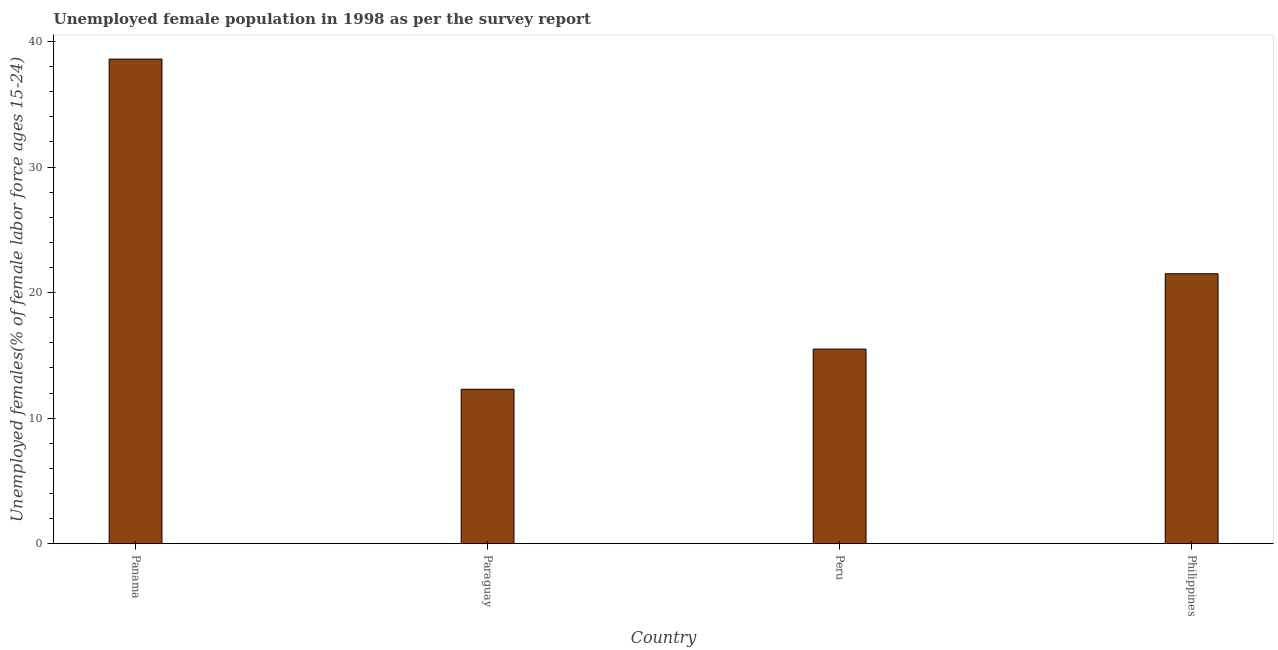What is the title of the graph?
Keep it short and to the point. Unemployed female population in 1998 as per the survey report. What is the label or title of the X-axis?
Provide a short and direct response. Country. What is the label or title of the Y-axis?
Offer a very short reply. Unemployed females(% of female labor force ages 15-24). What is the unemployed female youth in Philippines?
Keep it short and to the point. 21.5. Across all countries, what is the maximum unemployed female youth?
Provide a succinct answer. 38.6. Across all countries, what is the minimum unemployed female youth?
Give a very brief answer. 12.3. In which country was the unemployed female youth maximum?
Provide a short and direct response. Panama. In which country was the unemployed female youth minimum?
Offer a very short reply. Paraguay. What is the sum of the unemployed female youth?
Provide a succinct answer. 87.9. What is the difference between the unemployed female youth in Panama and Paraguay?
Ensure brevity in your answer.  26.3. What is the average unemployed female youth per country?
Provide a short and direct response. 21.98. What is the median unemployed female youth?
Ensure brevity in your answer.  18.5. In how many countries, is the unemployed female youth greater than 24 %?
Ensure brevity in your answer.  1. What is the ratio of the unemployed female youth in Paraguay to that in Peru?
Ensure brevity in your answer.  0.79. Is the difference between the unemployed female youth in Panama and Paraguay greater than the difference between any two countries?
Your response must be concise. Yes. What is the difference between the highest and the lowest unemployed female youth?
Give a very brief answer. 26.3. How many bars are there?
Keep it short and to the point. 4. How many countries are there in the graph?
Provide a short and direct response. 4. What is the difference between two consecutive major ticks on the Y-axis?
Give a very brief answer. 10. What is the Unemployed females(% of female labor force ages 15-24) of Panama?
Your answer should be compact. 38.6. What is the Unemployed females(% of female labor force ages 15-24) in Paraguay?
Your response must be concise. 12.3. What is the difference between the Unemployed females(% of female labor force ages 15-24) in Panama and Paraguay?
Offer a very short reply. 26.3. What is the difference between the Unemployed females(% of female labor force ages 15-24) in Panama and Peru?
Offer a very short reply. 23.1. What is the difference between the Unemployed females(% of female labor force ages 15-24) in Panama and Philippines?
Your response must be concise. 17.1. What is the difference between the Unemployed females(% of female labor force ages 15-24) in Paraguay and Philippines?
Give a very brief answer. -9.2. What is the ratio of the Unemployed females(% of female labor force ages 15-24) in Panama to that in Paraguay?
Make the answer very short. 3.14. What is the ratio of the Unemployed females(% of female labor force ages 15-24) in Panama to that in Peru?
Give a very brief answer. 2.49. What is the ratio of the Unemployed females(% of female labor force ages 15-24) in Panama to that in Philippines?
Your answer should be very brief. 1.79. What is the ratio of the Unemployed females(% of female labor force ages 15-24) in Paraguay to that in Peru?
Ensure brevity in your answer.  0.79. What is the ratio of the Unemployed females(% of female labor force ages 15-24) in Paraguay to that in Philippines?
Ensure brevity in your answer.  0.57. What is the ratio of the Unemployed females(% of female labor force ages 15-24) in Peru to that in Philippines?
Your response must be concise. 0.72. 